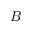<formula> <loc_0><loc_0><loc_500><loc_500>B</formula> 